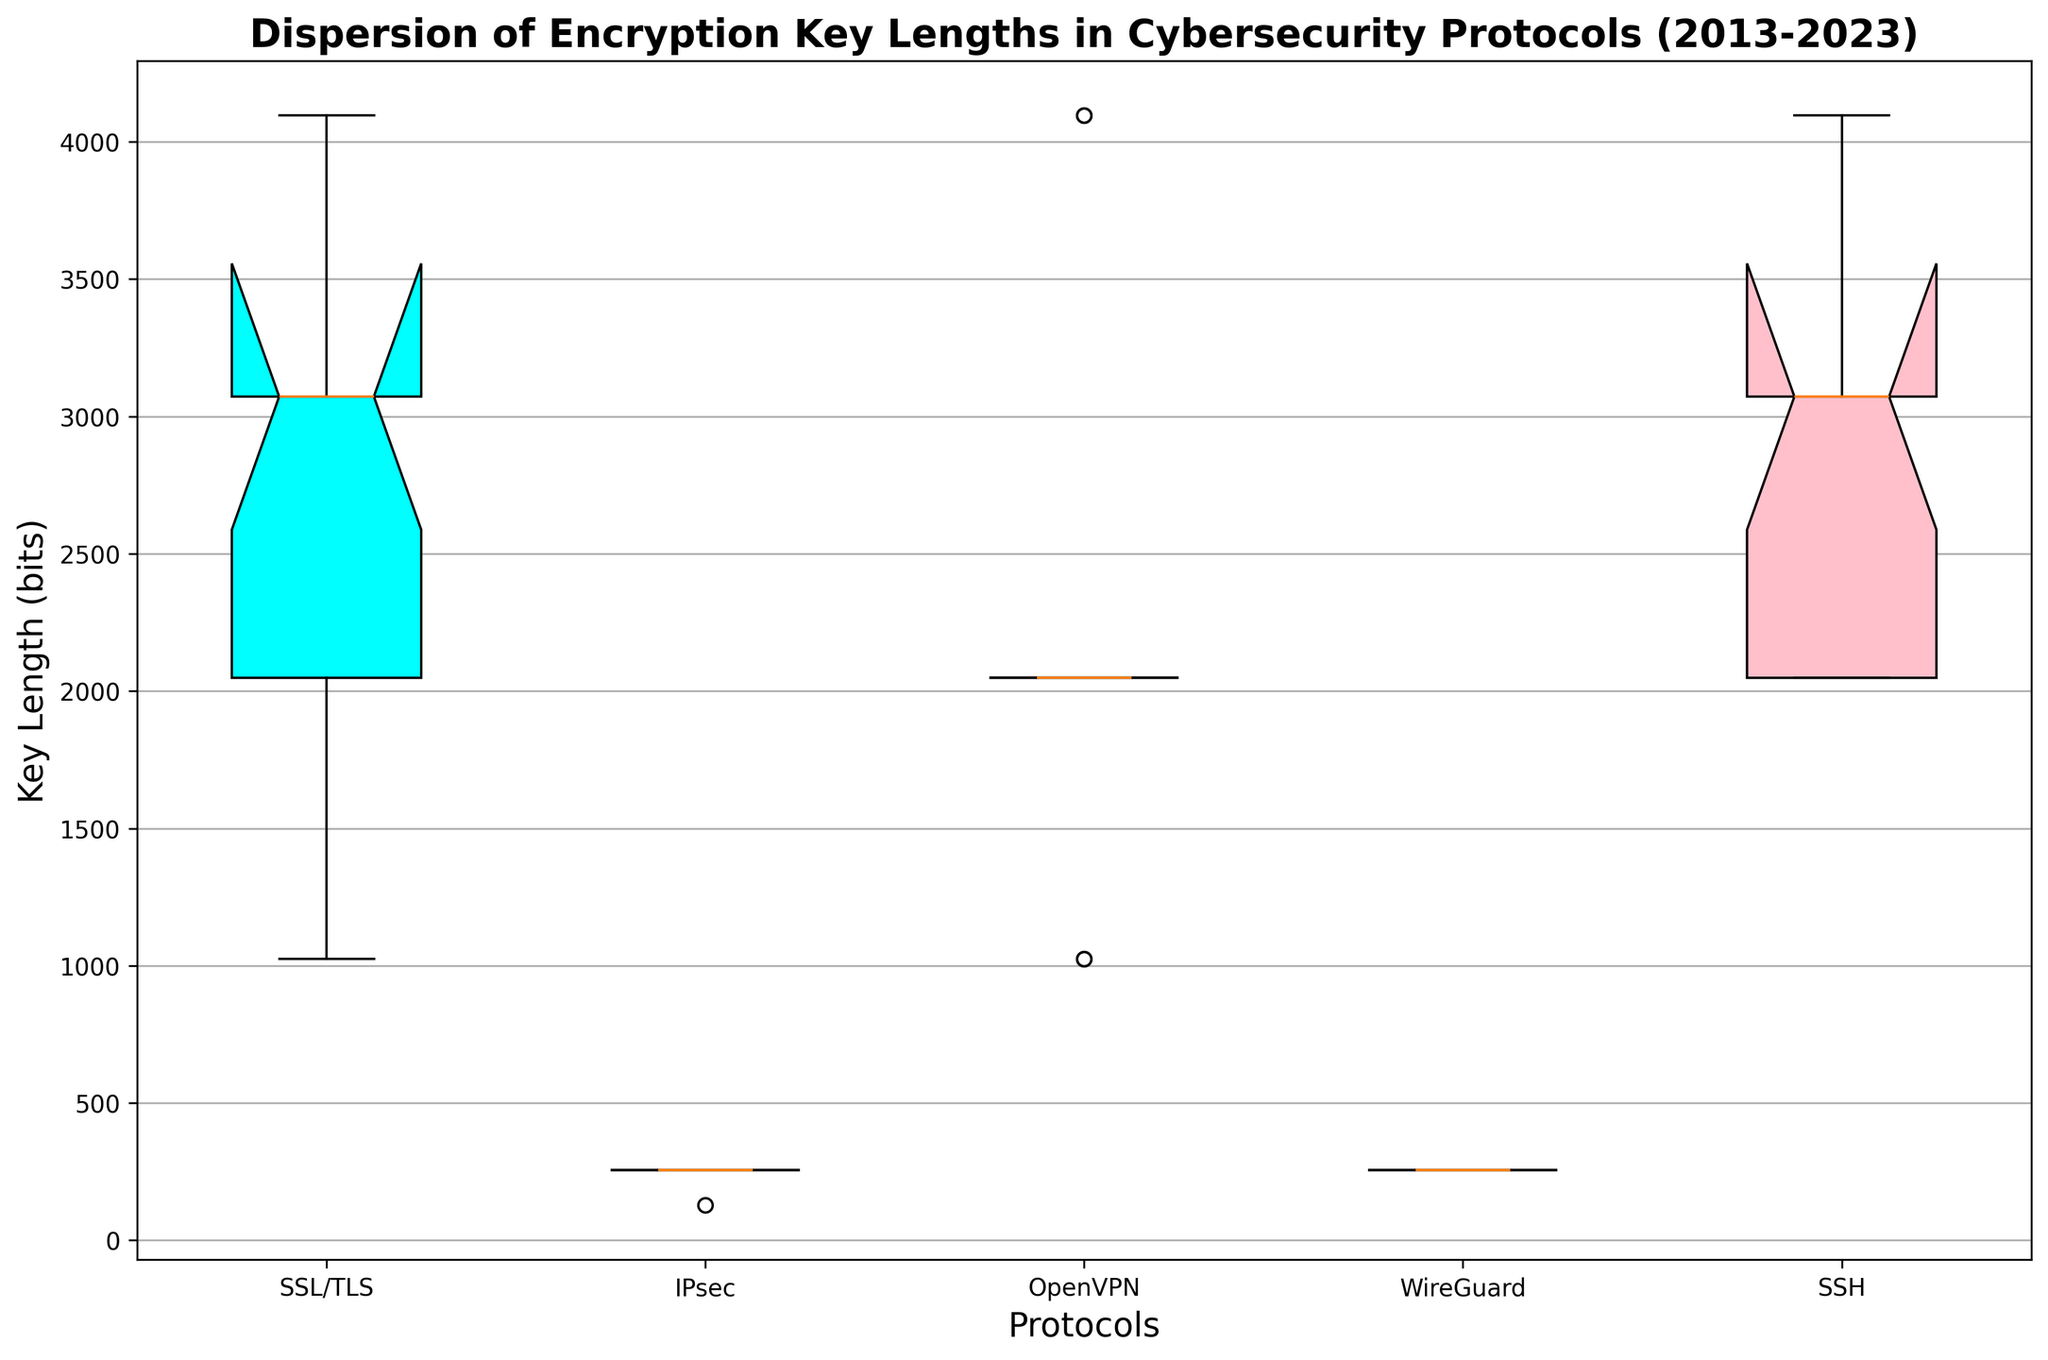Which protocol has the highest median key length? The height of the median line within each box plot indicates the median key length. If we look at the median lines, the SSL/TLS and SSH protocols both seem to have the highest median key lengths compared to others.
Answer: SSL/TLS and SSH Which protocol shows the most variation in encryption key lengths? The variation or dispersion within the data can be identified by looking at the heights of the box, whiskers, and any outliers. SSL/TLS displays the highest variation in encryption key lengths because its box and whiskers span a large range.
Answer: SSL/TLS How does the typical key length of WireGuard compare to that of OpenVPN from 2019 to 2023? WireGuard's box is very compressed, indicating little variation, primarily staying at 256 bits. OpenVPN's values show more variability, with lengths increasing significantly in 2022 and 2023.
Answer: WireGuard's key length is lower and less variable compared to OpenVPN's What is the interquartile range (IQR) of key lengths for the SSL/TLS protocol? The IQR is the distance between the 25th and 75th percentiles, represented by the lower and upper edges of the box. For SSL/TLS, the IQR spans from 2048 to 3072 bits.
Answer: 1024 bits Which protocols have a median key length of 256 bits? The median is represented by the line inside each box plot. A line at the 256-bit mark can be observed for IPsec and WireGuard protocols.
Answer: IPsec and WireGuard Have any protocols adopted a consistent key length over the past decade? If the box is very narrow with minimal whiskers, this indicates low variability and consistent key length. For IPsec and WireGuard, their boxes are practically lines, indicating consistent key lengths around 256 bits.
Answer: IPsec and WireGuard Is there a noticeable outlier in any of the protocols over the past decade? Outliers are typically represented by points outside the whiskers of a boxplot. By examining the boxplots, no specific outliers are apparent in the datasets for these protocols.
Answer: No How did the key length of the SSH protocol change over time from 2013 to 2023? Examine the direction and magnitude of changes in the boxplot years. The SSH protocol’s structure starts at 2048 bits and increases to 4096 bits over the years.
Answer: It increased Which protocol has the least interquartile range (IQR) and what does it indicate? The IQR is the width of the box. WireGuard and IPsec both have very low IQRs, indicating very little variation in key lengths.
Answer: WireGuard and IPsec indicate low variation 